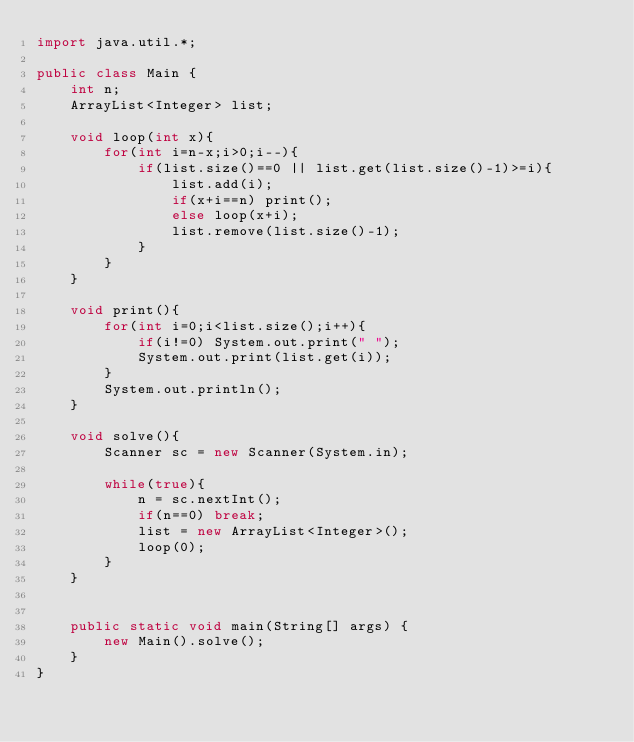<code> <loc_0><loc_0><loc_500><loc_500><_Java_>import java.util.*;

public class Main {
	int n;
	ArrayList<Integer> list;
	
	void loop(int x){
		for(int i=n-x;i>0;i--){
			if(list.size()==0 || list.get(list.size()-1)>=i){
				list.add(i);
				if(x+i==n) print();
				else loop(x+i);
				list.remove(list.size()-1);	
			}
		}
	}
	
	void print(){
		for(int i=0;i<list.size();i++){
			if(i!=0) System.out.print(" ");
			System.out.print(list.get(i));
		}
		System.out.println();
	}
	
	void solve(){
		Scanner sc = new Scanner(System.in);
		
		while(true){
			n = sc.nextInt();
			if(n==0) break;
			list = new ArrayList<Integer>();
			loop(0);
		}
	}
	
	
	public static void main(String[] args) {
		new Main().solve();
	}	
}</code> 